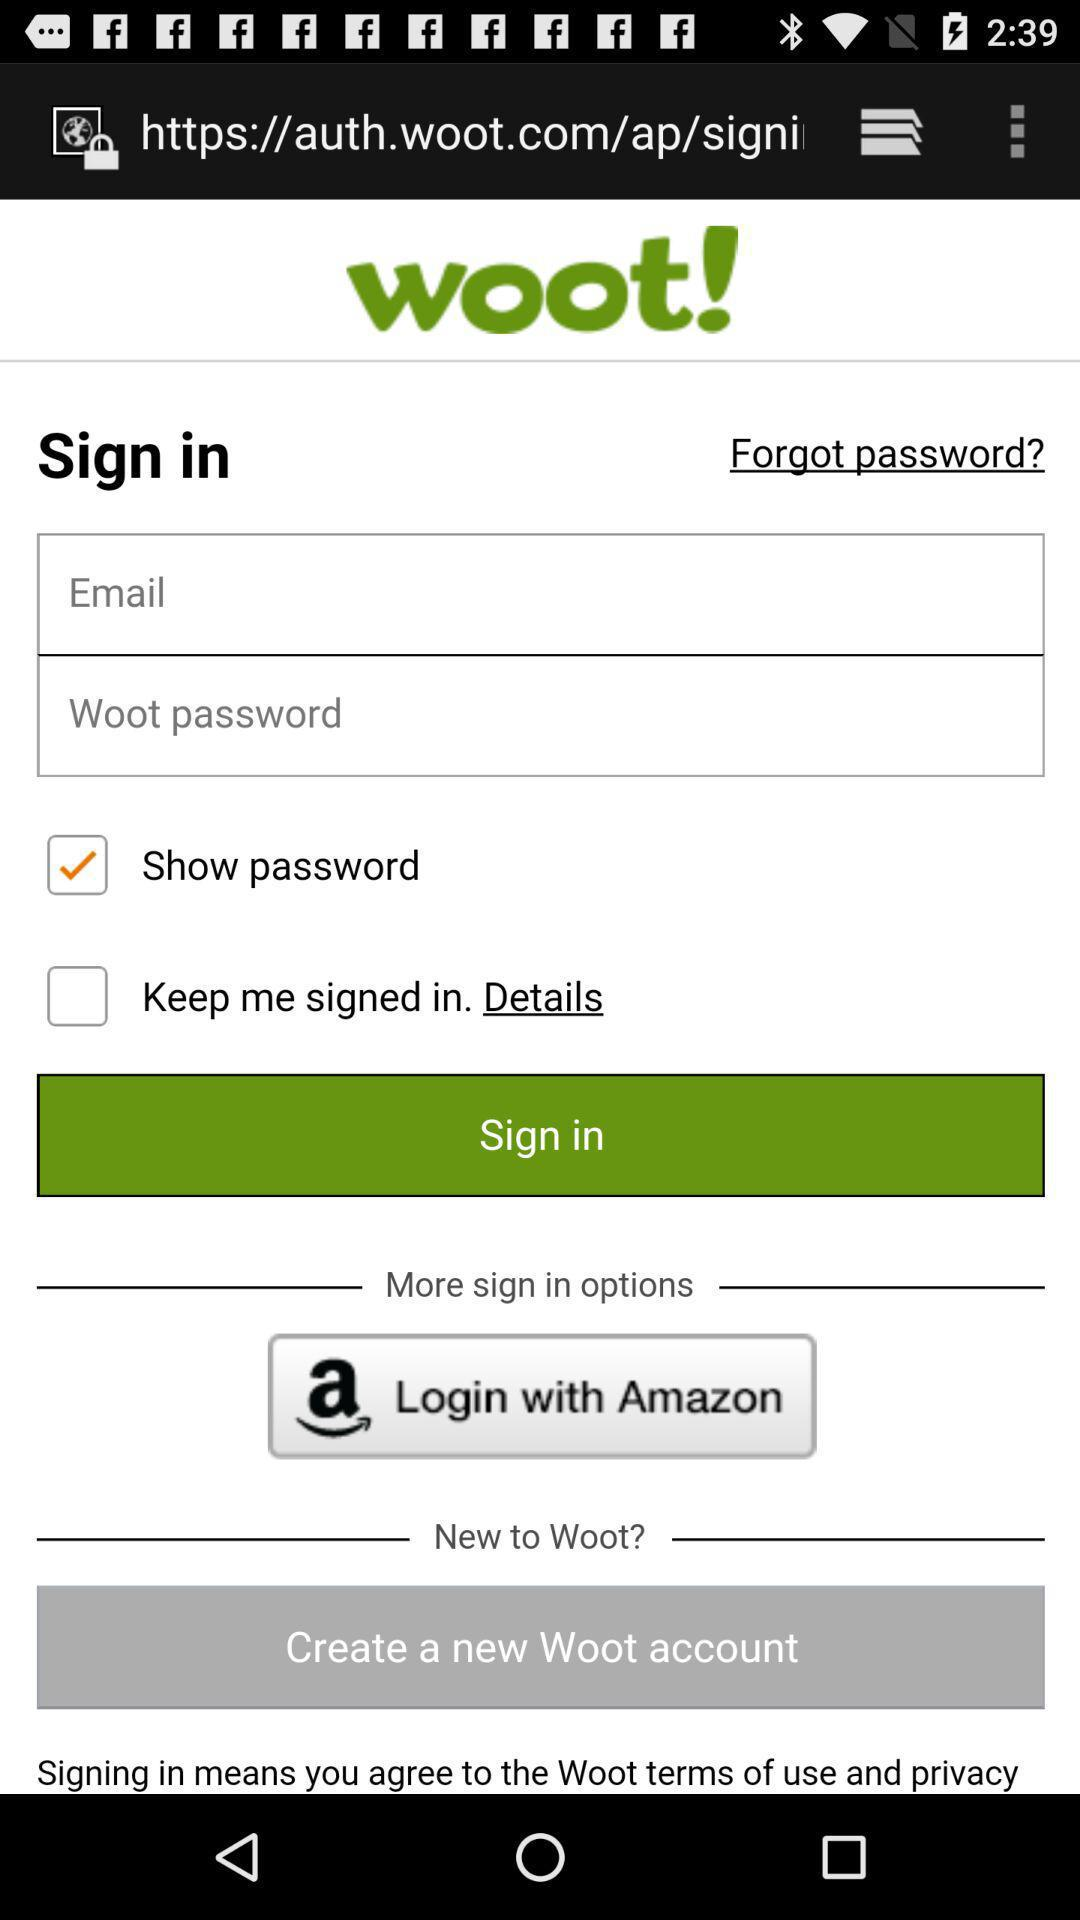What is the application name? The application name is "woot!". 